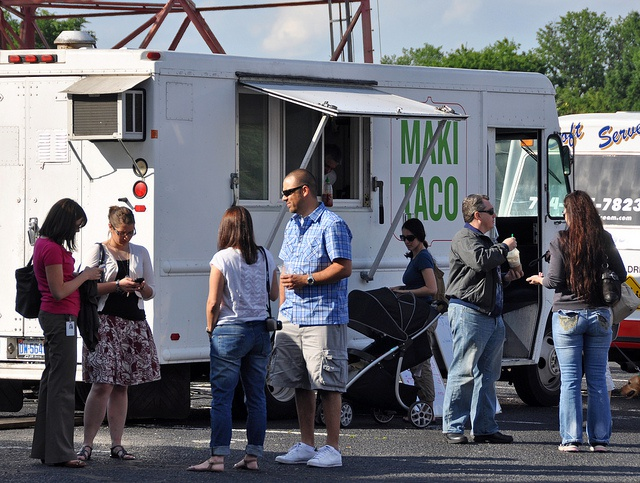Describe the objects in this image and their specific colors. I can see truck in black, gray, and white tones, people in black, gray, lightgray, and navy tones, people in black, gray, and navy tones, people in black, gray, and white tones, and people in black, gray, navy, and darkgray tones in this image. 